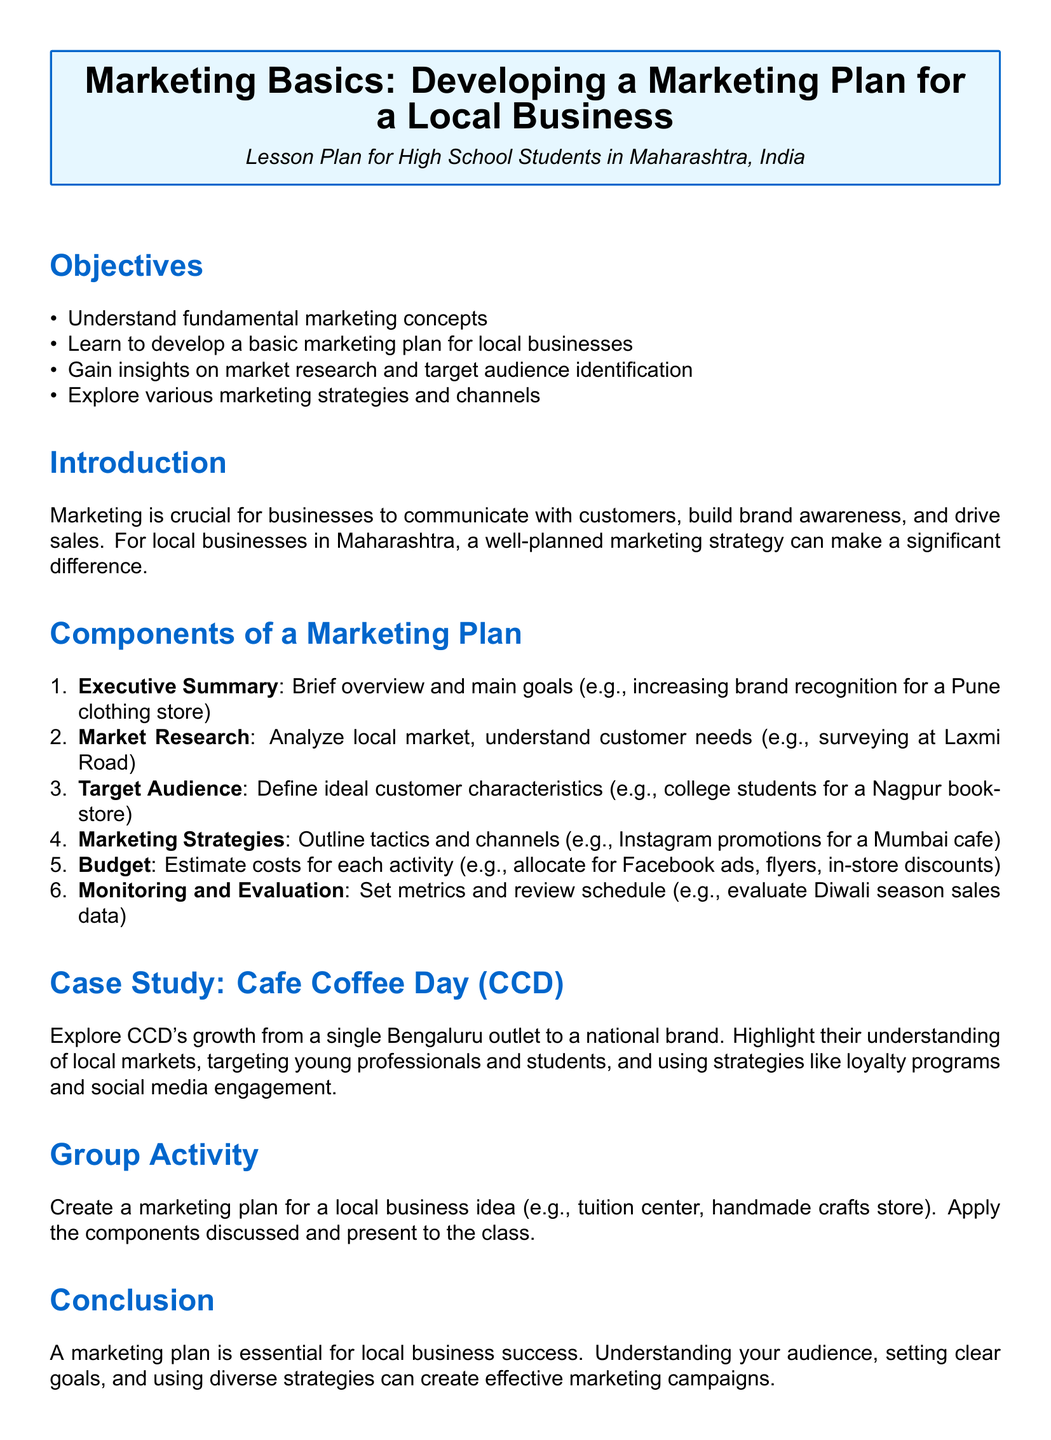what is the title of the lesson plan? The title of the lesson plan is presented in a prominent box at the beginning of the document.
Answer: Marketing Basics: Developing a Marketing Plan for a Local Business what is one objective of the lesson plan? The objectives are listed in a bullet format under the objectives section, focusing on what students should achieve.
Answer: Understand fundamental marketing concepts how many components are there in a marketing plan? The document enumerates the different parts of a marketing plan, indicating the total number.
Answer: Six give an example of a target audience for a marketing plan An example of a target audience is provided in the components thread, illustrating who a specific business aims to reach.
Answer: College students for a Nagpur bookstore which local business is used as a case study? The lesson plan includes a case study to provide a real-world example relevant to the marketing concepts being taught.
Answer: Cafe Coffee Day (CCD) what is one marketing strategy mentioned in the lesson plan? The marketing strategies section lists various tactics, illustrating what businesses can use to engage their audience.
Answer: Instagram promotions for a Mumbai cafe what is the focus of the introduction section? The introduction provides context on the importance of marketing for businesses, helping to set the stage for the students.
Answer: Marketing is crucial for businesses what is the final section of the document called? The last section summarizes the key takeaways from the lesson, reinforcing the main points discussed earlier.
Answer: Conclusion 